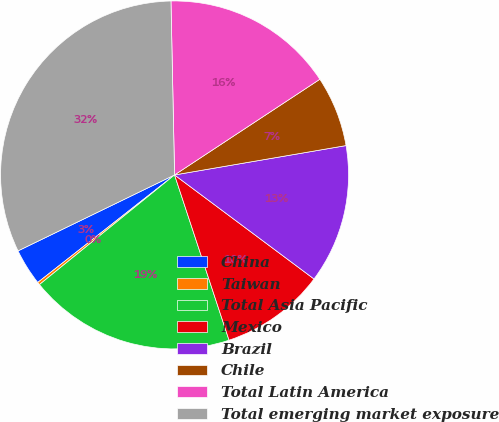Convert chart to OTSL. <chart><loc_0><loc_0><loc_500><loc_500><pie_chart><fcel>China<fcel>Taiwan<fcel>Total Asia Pacific<fcel>Mexico<fcel>Brazil<fcel>Chile<fcel>Total Latin America<fcel>Total emerging market exposure<nl><fcel>3.41%<fcel>0.25%<fcel>19.22%<fcel>9.73%<fcel>12.9%<fcel>6.57%<fcel>16.06%<fcel>31.86%<nl></chart> 